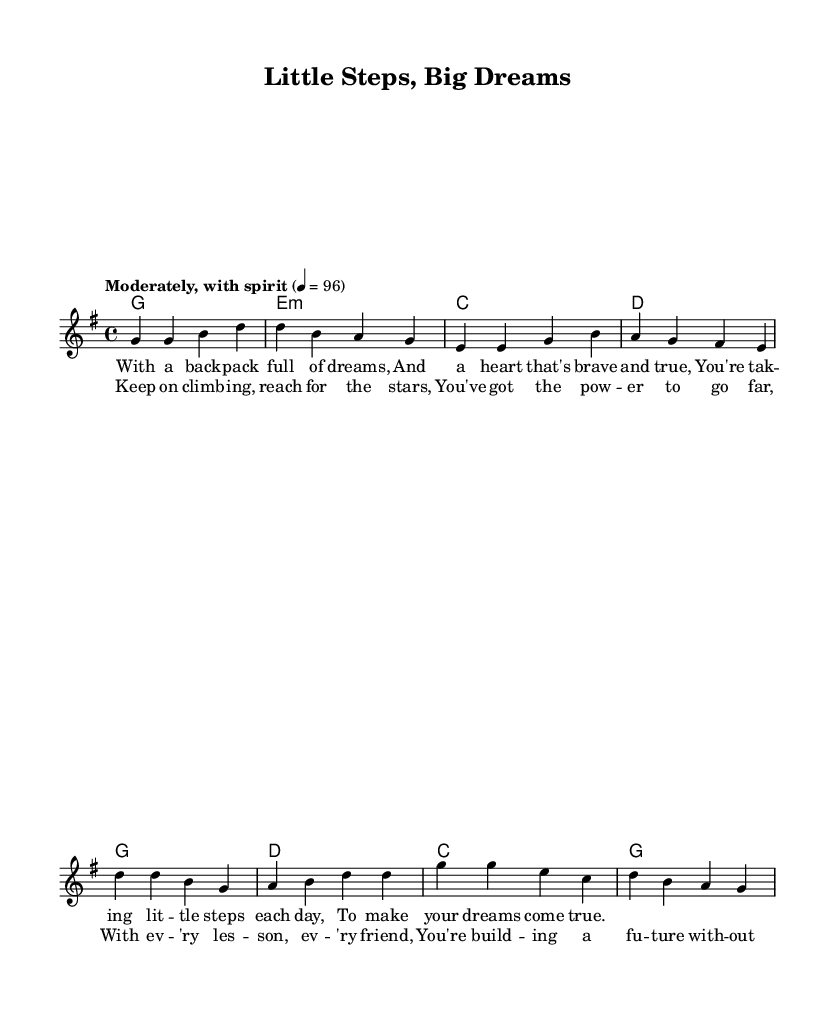What is the key signature of this music? The key signature is in G major, which has one sharp (F#). This can be confirmed by looking at the key signature indicated at the beginning of the sheet music.
Answer: G major What is the time signature of this music? The time signature is 4/4, indicating four beats per measure and a quarter note receiving one beat. This is clearly shown at the beginning of the piece.
Answer: 4/4 What is the tempo marking for this music? The tempo marking is "Moderately, with spirit" set at 96 beats per minute. This is indicated below the title and provides guidance for the pace of the performance.
Answer: Moderately, with spirit How many measures are in the verse? The verse comprises four measures, as seen in the melody and identified by the individual divisions in the notation. Each group of notes represents a measure.
Answer: Four What are the main themes of the lyrics? The main themes of the lyrics are dreams, bravery, and progress. By analyzing the lyrics' content, we see they encourage pursuing dreams and celebrating small achievements, which are central for young dreamers.
Answer: Dreams, bravery, progress In which section of the song is the repeated phrase "Keep on climbing, reach for the stars"? This phrase appears in the chorus section of the song. By reviewing the lyric layout, it is evident that this phrase is part of the repeated lyrics that typically follow the verses.
Answer: Chorus 